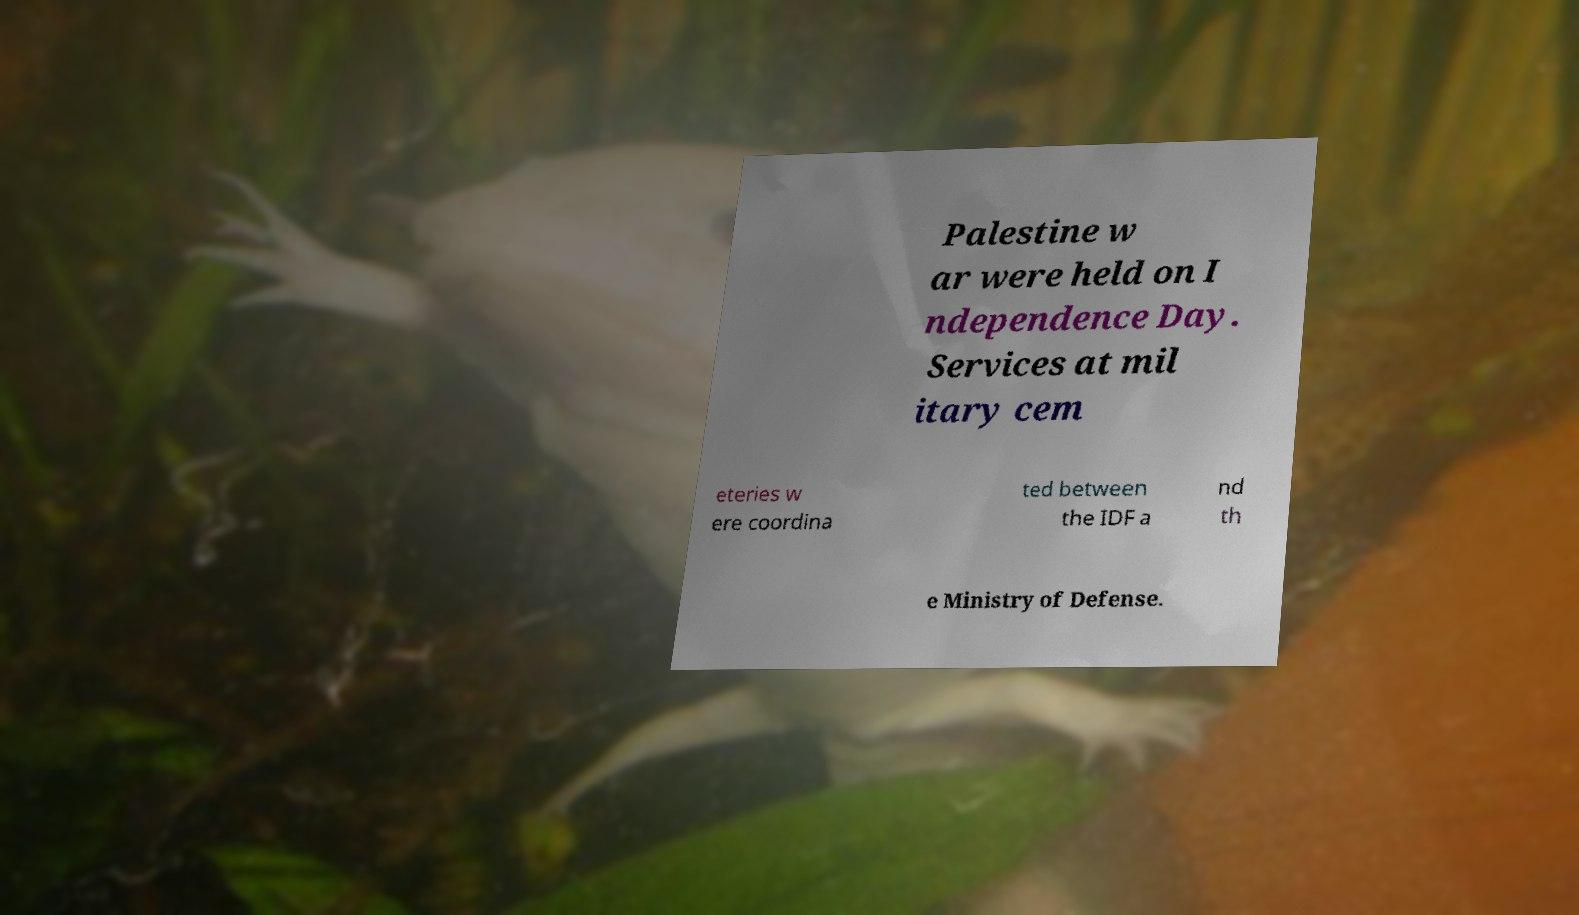I need the written content from this picture converted into text. Can you do that? Palestine w ar were held on I ndependence Day. Services at mil itary cem eteries w ere coordina ted between the IDF a nd th e Ministry of Defense. 